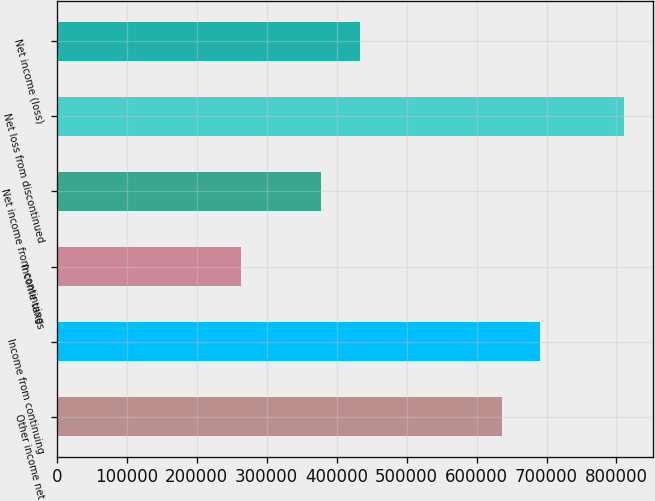<chart> <loc_0><loc_0><loc_500><loc_500><bar_chart><fcel>Other income net<fcel>Income from continuing<fcel>Income taxes<fcel>Net income from continuing<fcel>Net loss from discontinued<fcel>Net income (loss)<nl><fcel>635798<fcel>690570<fcel>263504<fcel>377261<fcel>811224<fcel>433963<nl></chart> 